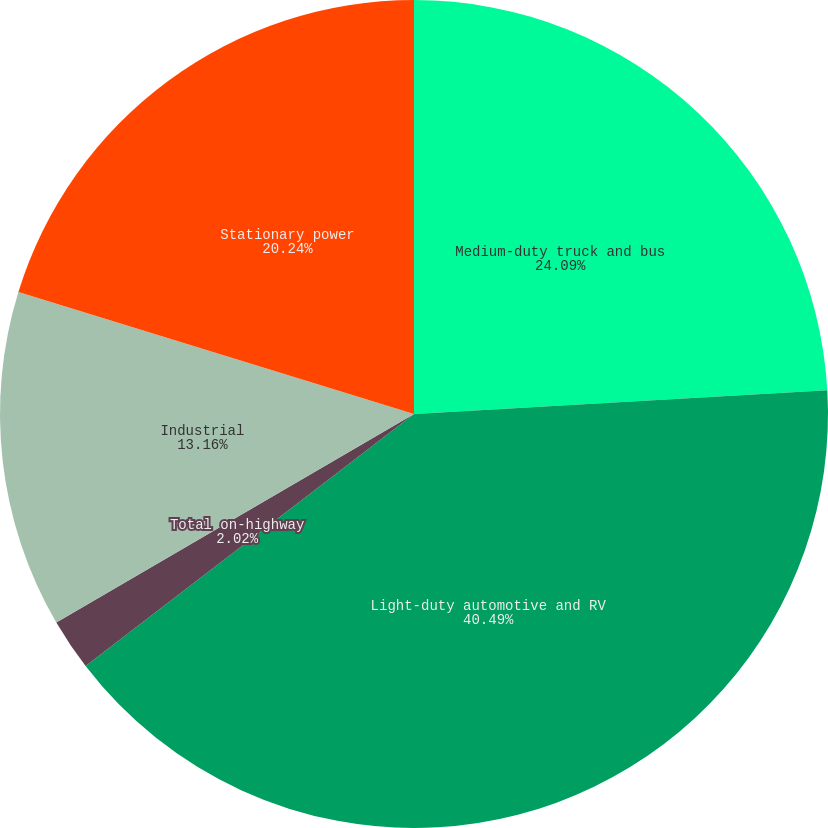Convert chart to OTSL. <chart><loc_0><loc_0><loc_500><loc_500><pie_chart><fcel>Medium-duty truck and bus<fcel>Light-duty automotive and RV<fcel>Total on-highway<fcel>Industrial<fcel>Stationary power<nl><fcel>24.09%<fcel>40.49%<fcel>2.02%<fcel>13.16%<fcel>20.24%<nl></chart> 